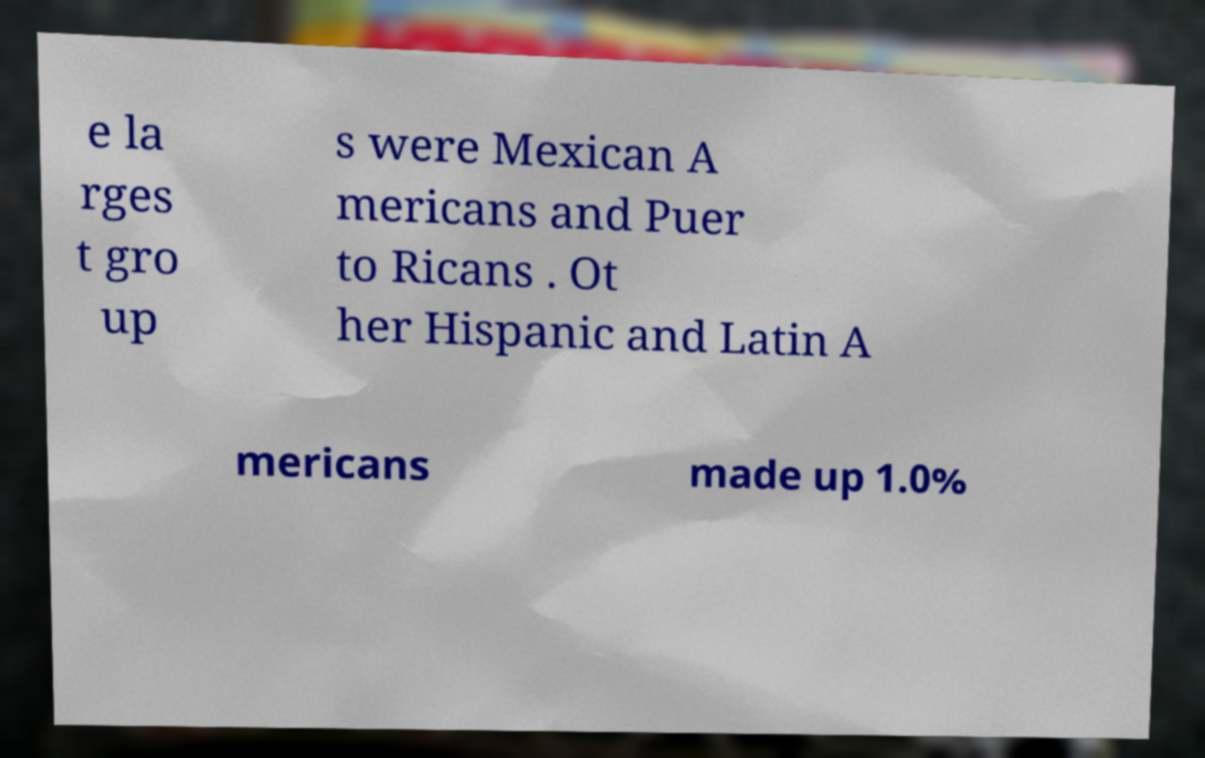For documentation purposes, I need the text within this image transcribed. Could you provide that? e la rges t gro up s were Mexican A mericans and Puer to Ricans . Ot her Hispanic and Latin A mericans made up 1.0% 